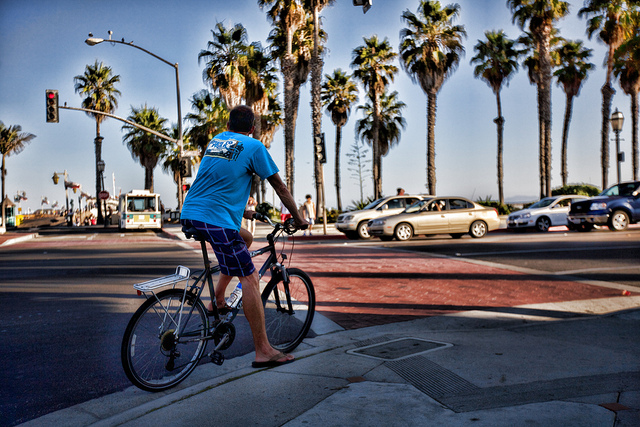Looking at this image, what might be some of the health or environmental benefits of the kind of transportation shown? Cycling, as shown in the image, offers numerous health benefits including improved cardiovascular fitness, increased muscle strength and flexibility, enhanced joint mobility, and reduced stress levels. Environmentally, it is a sustainable mode of transport that reduces traffic congestion, minimizes carbon emissions compared to motorized vehicles, and contributes to cleaner air and reduced noise pollution. It is a green transportation option that promotes a more active lifestyle while also being eco-friendly. 